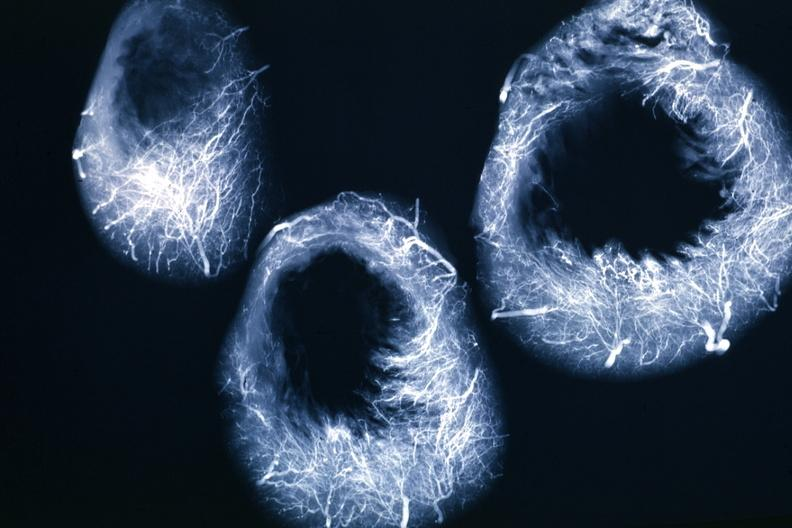where is this from?
Answer the question using a single word or phrase. Heart 